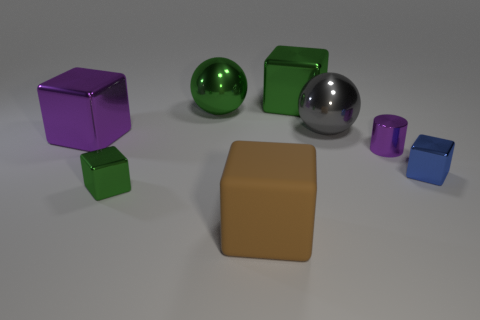Subtract all rubber blocks. How many blocks are left? 4 Subtract all blue blocks. How many blocks are left? 4 Subtract all yellow blocks. Subtract all yellow balls. How many blocks are left? 5 Add 1 small green objects. How many objects exist? 9 Subtract all spheres. How many objects are left? 6 Add 1 large matte cylinders. How many large matte cylinders exist? 1 Subtract 0 blue cylinders. How many objects are left? 8 Subtract all small things. Subtract all purple blocks. How many objects are left? 4 Add 7 spheres. How many spheres are left? 9 